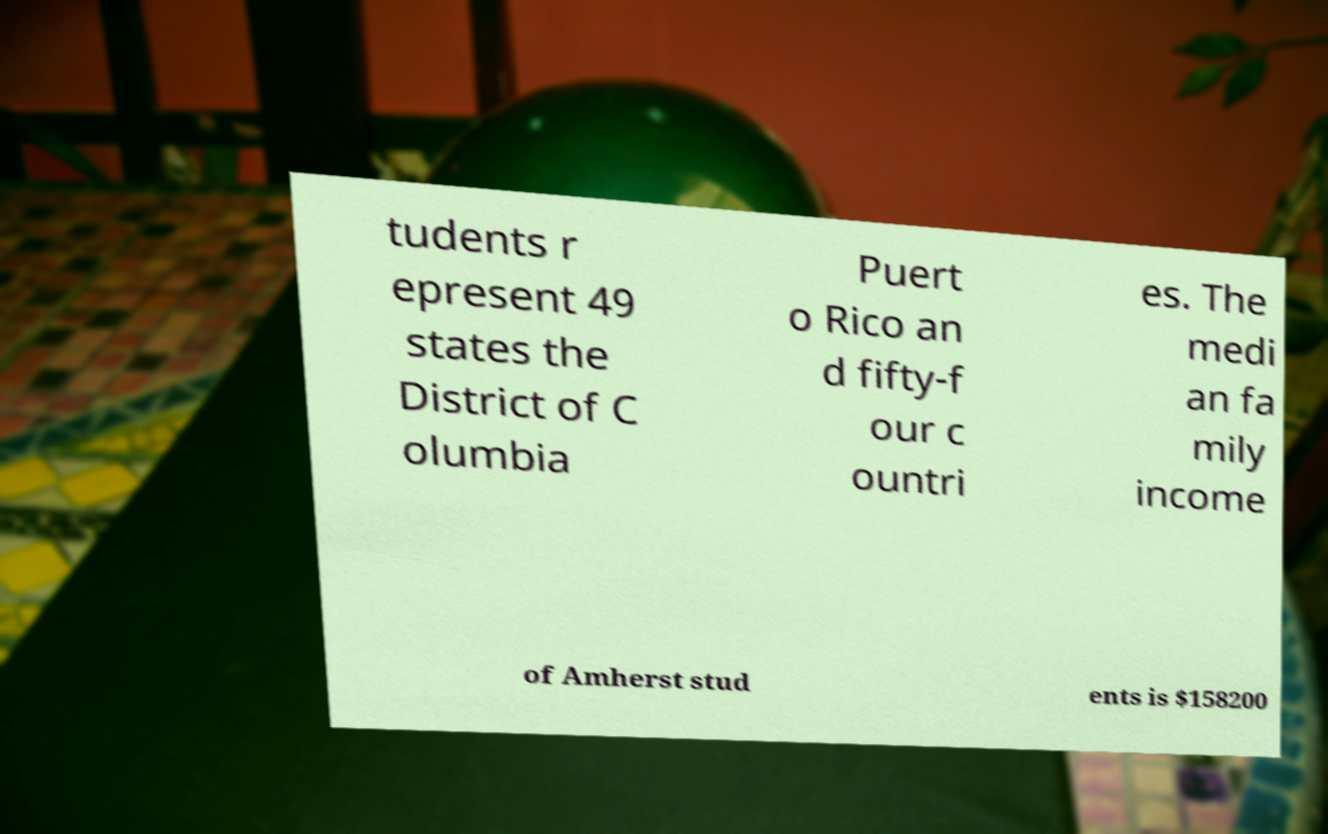Please identify and transcribe the text found in this image. tudents r epresent 49 states the District of C olumbia Puert o Rico an d fifty-f our c ountri es. The medi an fa mily income of Amherst stud ents is $158200 